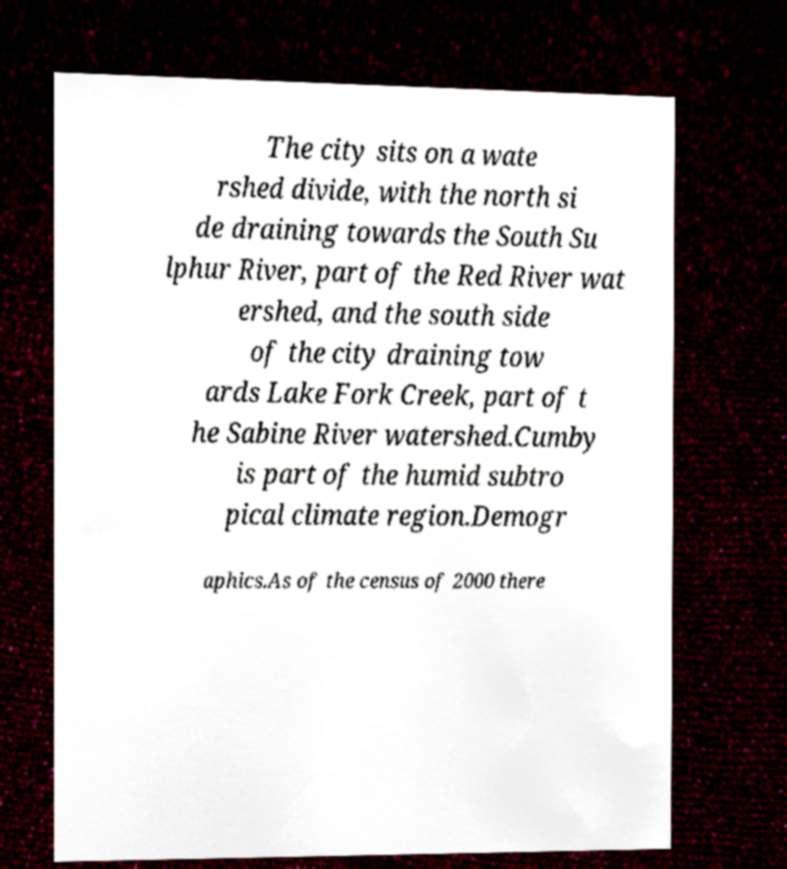Could you assist in decoding the text presented in this image and type it out clearly? The city sits on a wate rshed divide, with the north si de draining towards the South Su lphur River, part of the Red River wat ershed, and the south side of the city draining tow ards Lake Fork Creek, part of t he Sabine River watershed.Cumby is part of the humid subtro pical climate region.Demogr aphics.As of the census of 2000 there 